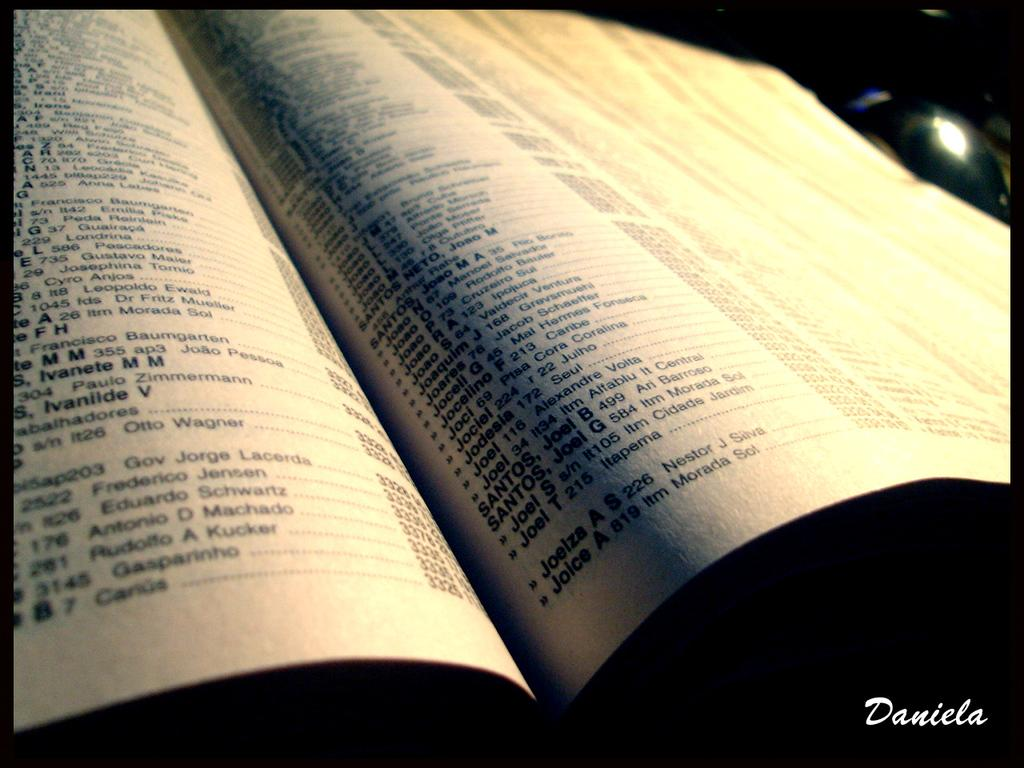<image>
Present a compact description of the photo's key features. An up close shot of a phonebook with the name Daniela written in the bottom right. 